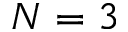Convert formula to latex. <formula><loc_0><loc_0><loc_500><loc_500>N = 3</formula> 